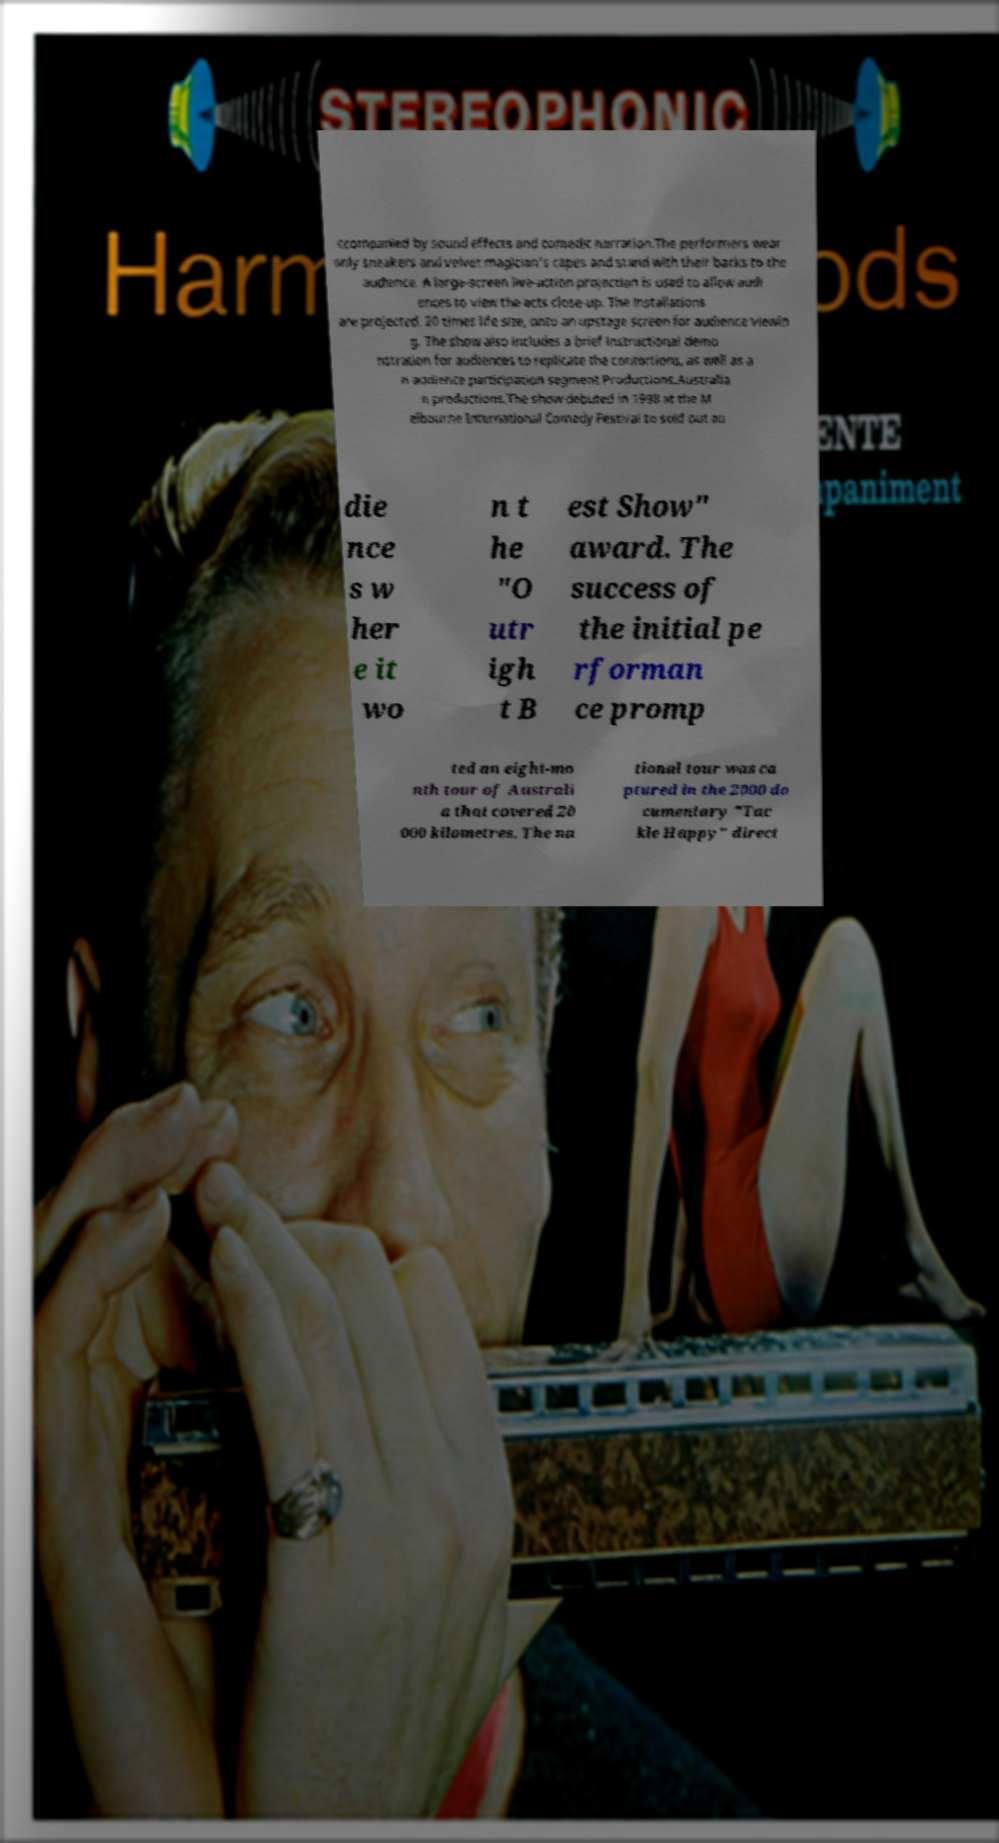Please identify and transcribe the text found in this image. ccompanied by sound effects and comedic narration.The performers wear only sneakers and velvet magician's capes and stand with their backs to the audience. A large-screen live-action projection is used to allow audi ences to view the acts close-up. The installations are projected, 20 times life size, onto an upstage screen for audience viewin g. The show also includes a brief instructional demo nstration for audiences to replicate the contortions, as well as a n audience participation segment.Productions.Australia n productions.The show debuted in 1998 at the M elbourne International Comedy Festival to sold out au die nce s w her e it wo n t he "O utr igh t B est Show" award. The success of the initial pe rforman ce promp ted an eight-mo nth tour of Australi a that covered 20 000 kilometres. The na tional tour was ca ptured in the 2000 do cumentary "Tac kle Happy" direct 